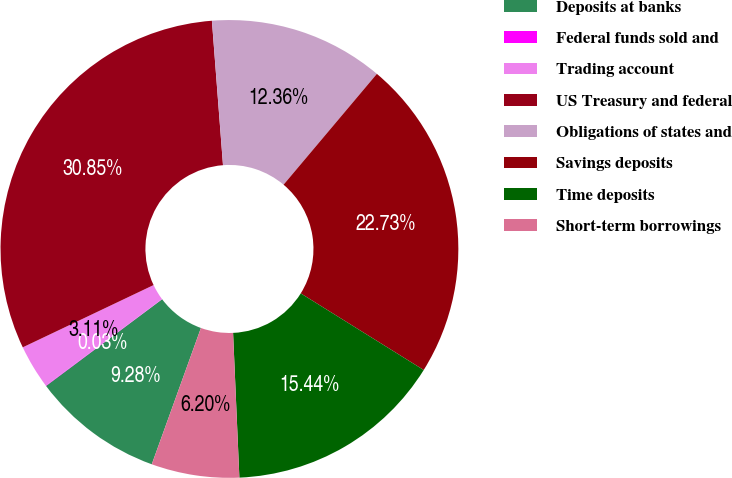Convert chart to OTSL. <chart><loc_0><loc_0><loc_500><loc_500><pie_chart><fcel>Deposits at banks<fcel>Federal funds sold and<fcel>Trading account<fcel>US Treasury and federal<fcel>Obligations of states and<fcel>Savings deposits<fcel>Time deposits<fcel>Short-term borrowings<nl><fcel>9.28%<fcel>0.03%<fcel>3.11%<fcel>30.85%<fcel>12.36%<fcel>22.73%<fcel>15.44%<fcel>6.2%<nl></chart> 